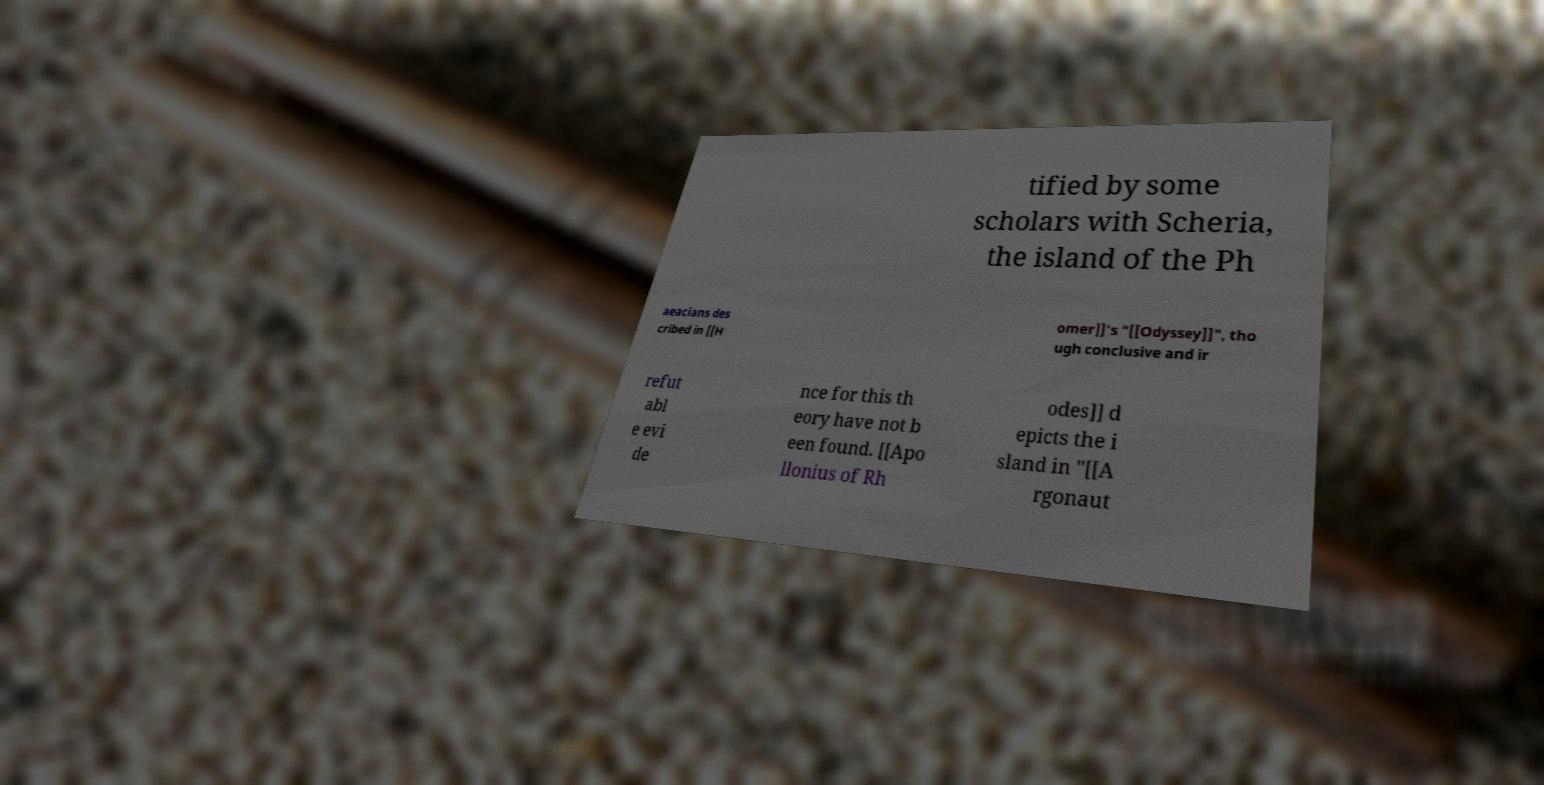Could you extract and type out the text from this image? tified by some scholars with Scheria, the island of the Ph aeacians des cribed in [[H omer]]'s "[[Odyssey]]", tho ugh conclusive and ir refut abl e evi de nce for this th eory have not b een found. [[Apo llonius of Rh odes]] d epicts the i sland in "[[A rgonaut 